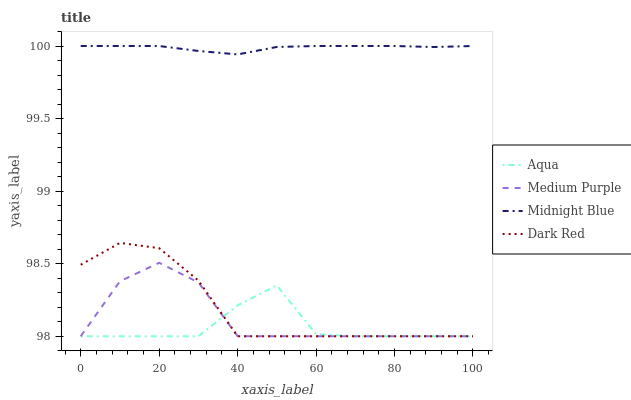Does Aqua have the minimum area under the curve?
Answer yes or no. Yes. Does Midnight Blue have the maximum area under the curve?
Answer yes or no. Yes. Does Dark Red have the minimum area under the curve?
Answer yes or no. No. Does Dark Red have the maximum area under the curve?
Answer yes or no. No. Is Midnight Blue the smoothest?
Answer yes or no. Yes. Is Medium Purple the roughest?
Answer yes or no. Yes. Is Dark Red the smoothest?
Answer yes or no. No. Is Dark Red the roughest?
Answer yes or no. No. Does Medium Purple have the lowest value?
Answer yes or no. Yes. Does Midnight Blue have the lowest value?
Answer yes or no. No. Does Midnight Blue have the highest value?
Answer yes or no. Yes. Does Dark Red have the highest value?
Answer yes or no. No. Is Dark Red less than Midnight Blue?
Answer yes or no. Yes. Is Midnight Blue greater than Aqua?
Answer yes or no. Yes. Does Dark Red intersect Aqua?
Answer yes or no. Yes. Is Dark Red less than Aqua?
Answer yes or no. No. Is Dark Red greater than Aqua?
Answer yes or no. No. Does Dark Red intersect Midnight Blue?
Answer yes or no. No. 